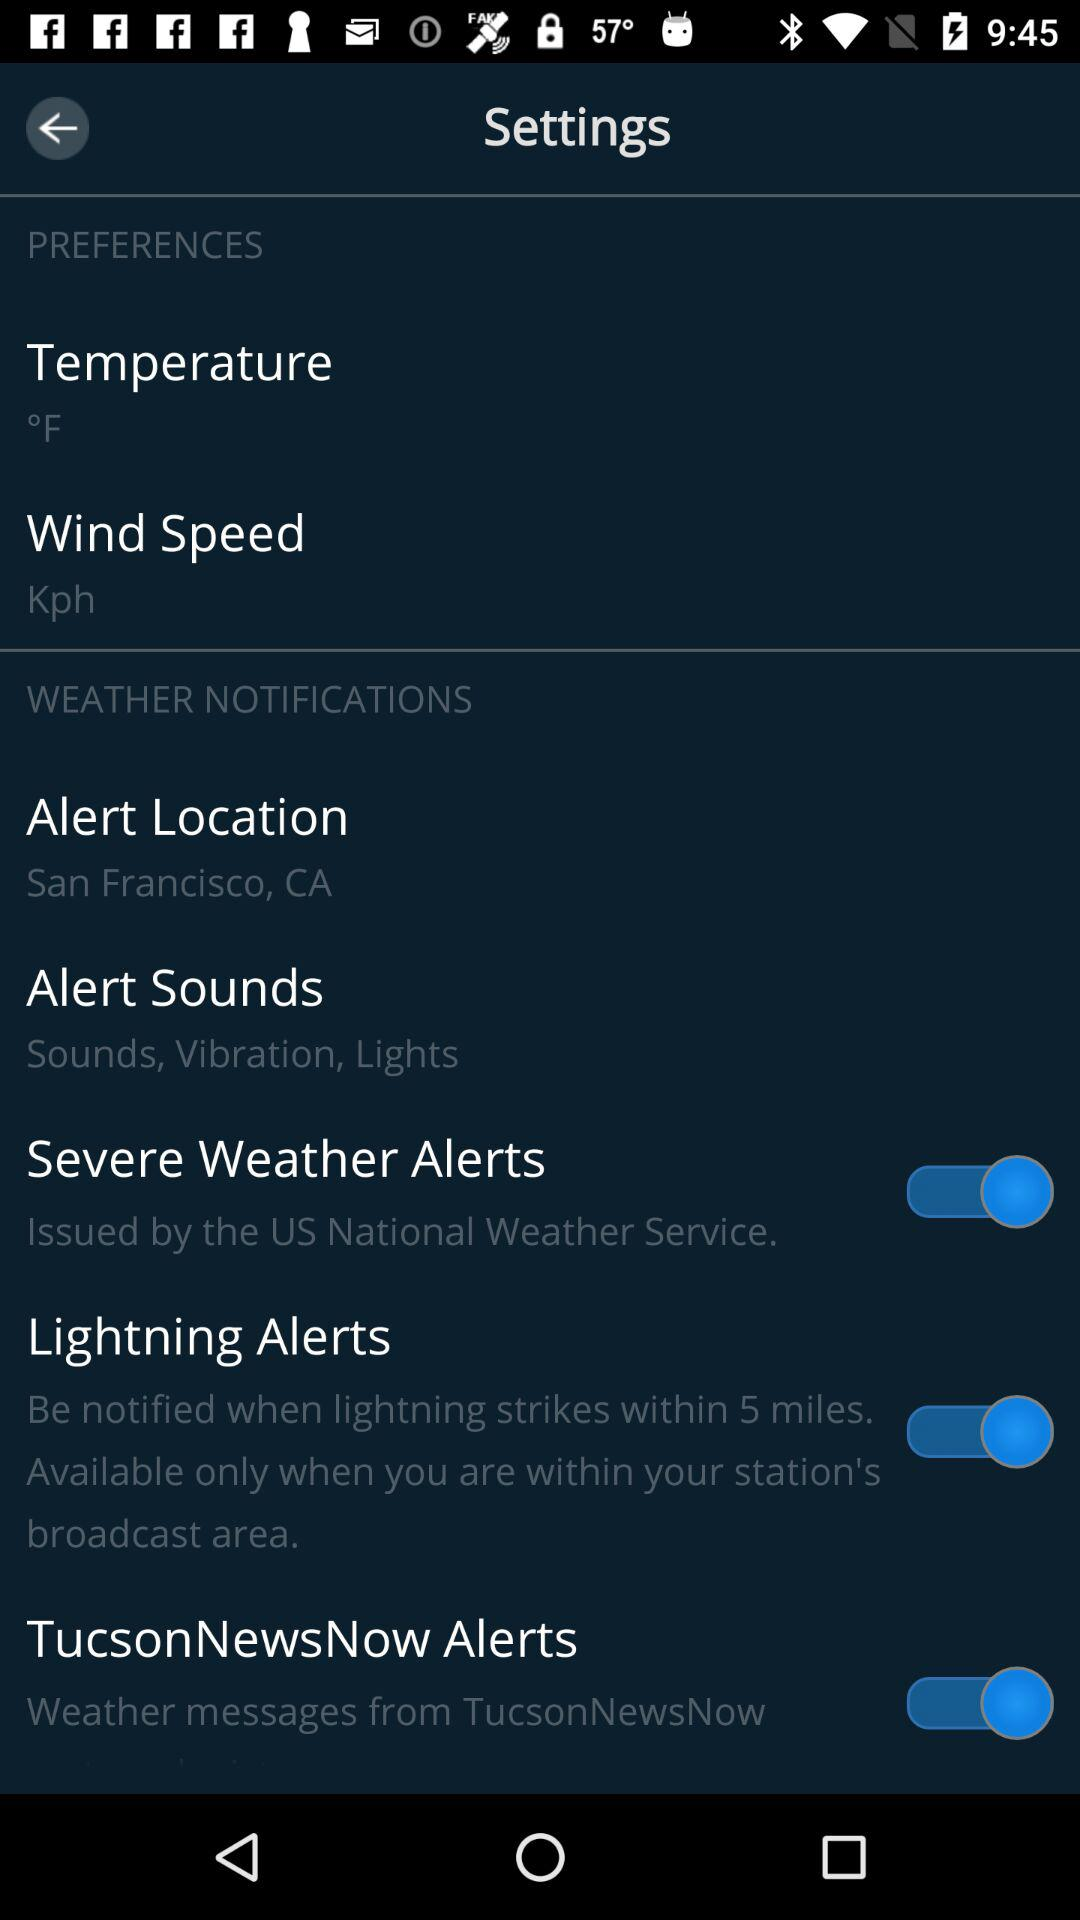Is changing the temperature unit to Celsius an option?
When the provided information is insufficient, respond with <no answer>. <no answer> 